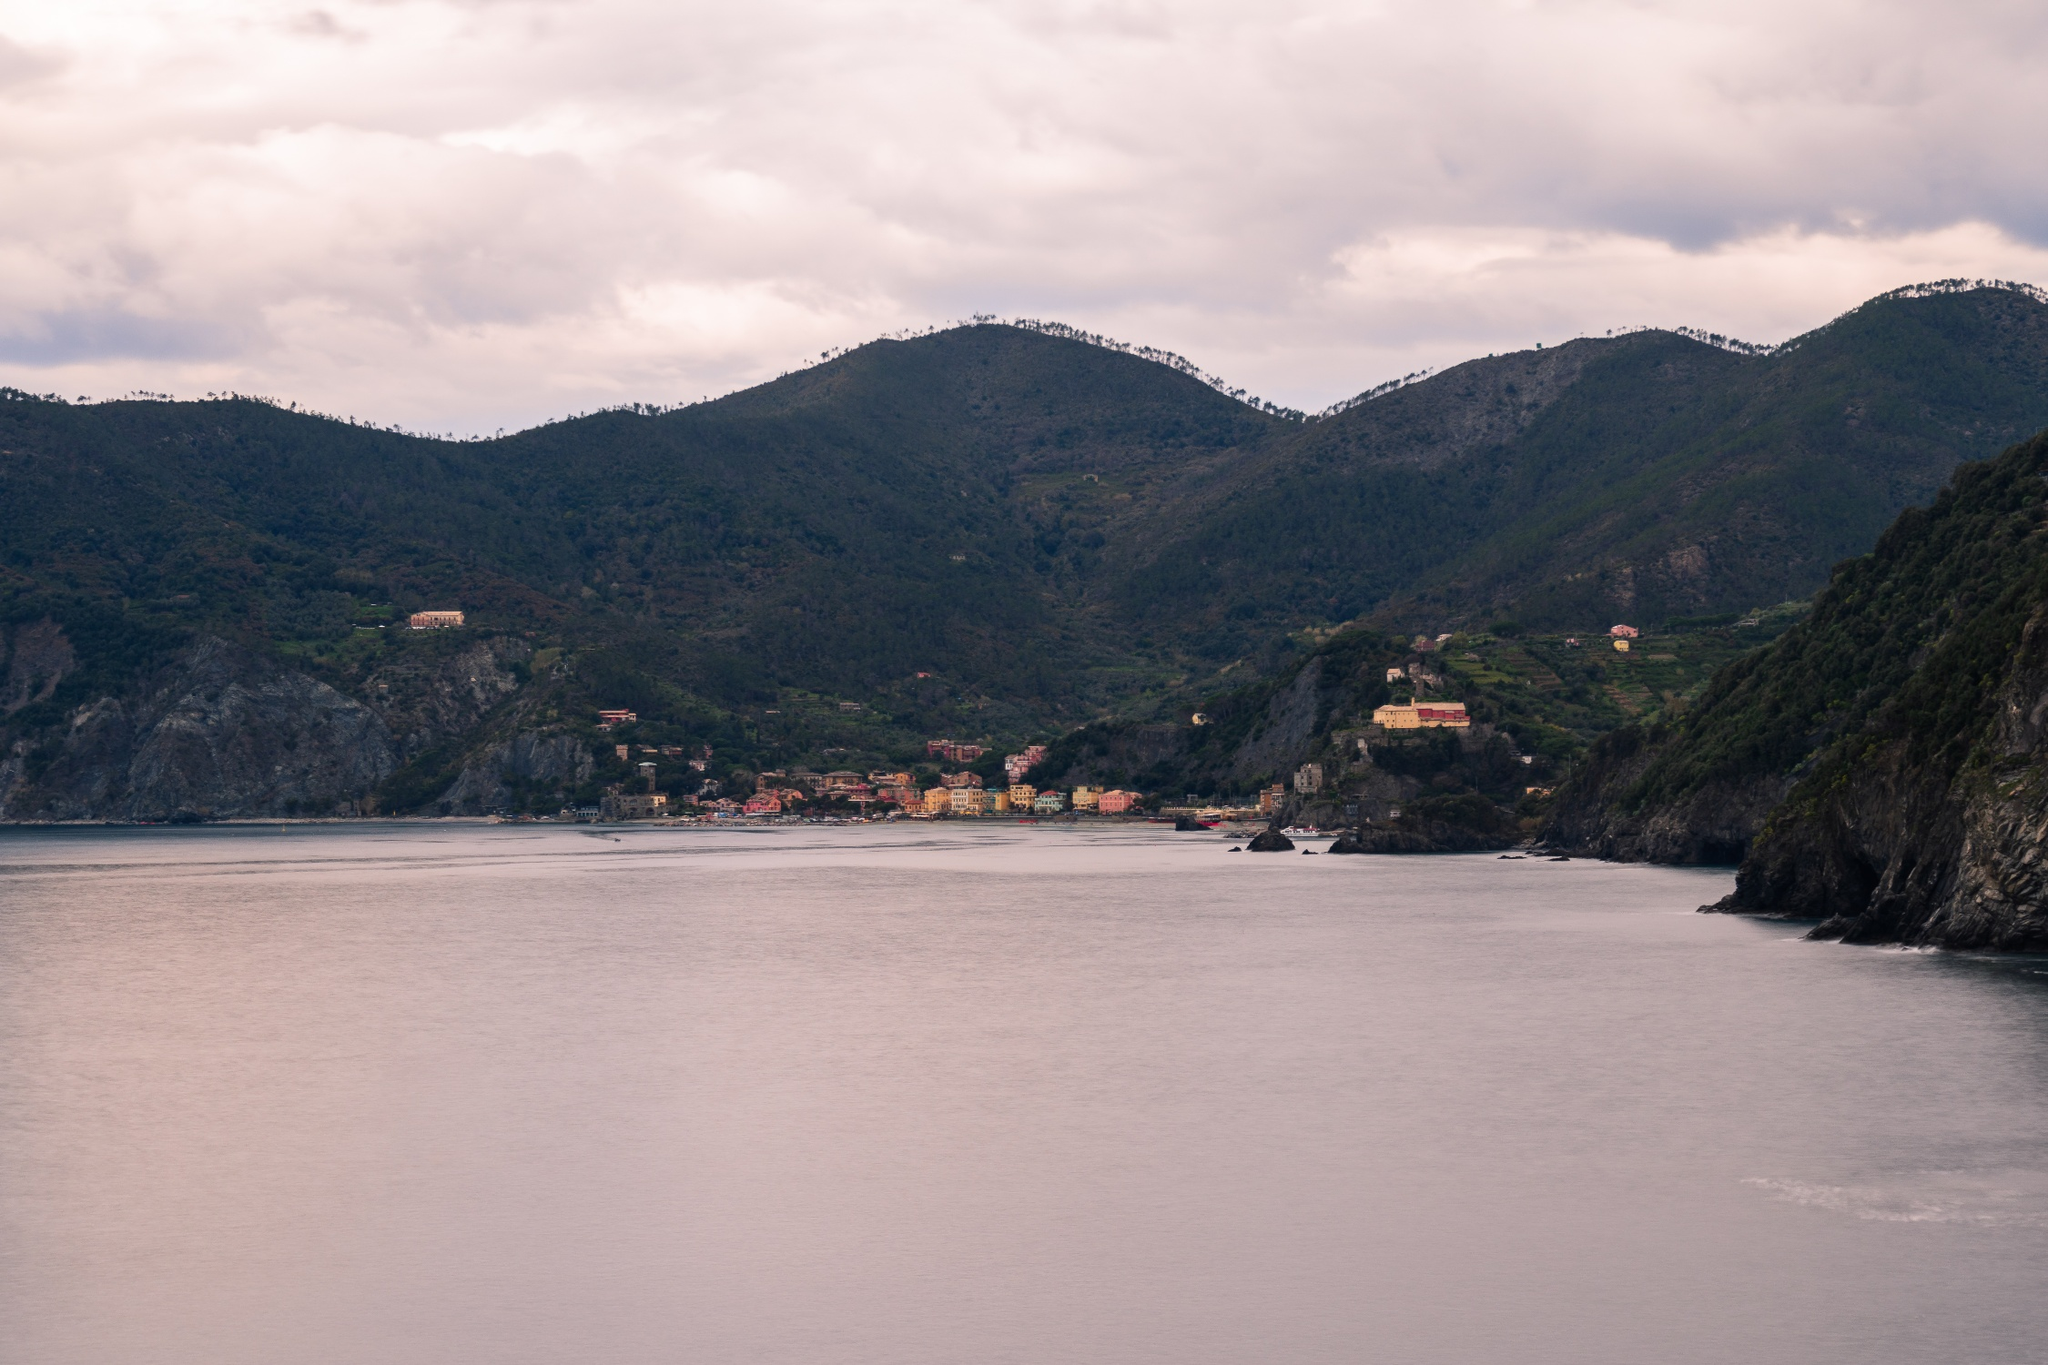Given the tranquil atmosphere, what are some realistic scenarios that could unfold here? A peaceful morning in the town begins with fishermen preparing their boats, the soft hum of their engines mingling with the gentle lapping of waves. Local markets open with the aroma of freshly baked bread and pastries, as residents and early tourists stroll through the narrow streets. Children play by the waterfront, their laughter echoing against the cliffs. In the evening, the town lights up softly as residents gather in small, cozy restaurants, sharing stories over dinner and watching the sunset paint the sky in hues of orange and pink. What about another realistic scenario, perhaps involving a special event or activity? During the summer, the town hosts an annual seaside festival celebrating its rich maritime heritage. The event features traditional boat races, where local fishermen and hobbyists alike compete, their sails billowing against the backdrop of the sea and cliffs. Stalls line the waterfront, offering an array of local delicacies, handcrafted items, and artwork. As the sun begins to set, the town square transforms into a lively scene with music, dancing, and vibrant performances celebrating both local traditions and contemporary culture. The evening culminates in a spectacular fireworks display over the water, illuminating the faces of locals and visitors who gather to share in the joyous celebrations. 